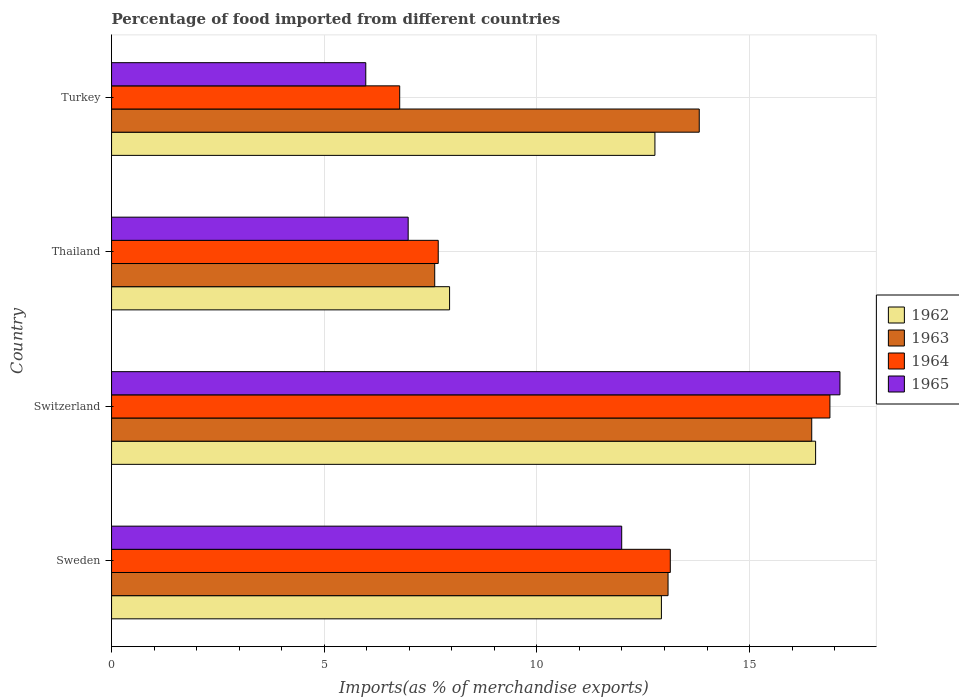How many different coloured bars are there?
Offer a terse response. 4. How many groups of bars are there?
Offer a terse response. 4. Are the number of bars on each tick of the Y-axis equal?
Offer a terse response. Yes. How many bars are there on the 4th tick from the top?
Offer a terse response. 4. How many bars are there on the 1st tick from the bottom?
Make the answer very short. 4. What is the label of the 2nd group of bars from the top?
Make the answer very short. Thailand. What is the percentage of imports to different countries in 1965 in Switzerland?
Make the answer very short. 17.12. Across all countries, what is the maximum percentage of imports to different countries in 1965?
Give a very brief answer. 17.12. Across all countries, what is the minimum percentage of imports to different countries in 1962?
Your response must be concise. 7.95. In which country was the percentage of imports to different countries in 1963 maximum?
Your answer should be very brief. Switzerland. In which country was the percentage of imports to different countries in 1962 minimum?
Provide a succinct answer. Thailand. What is the total percentage of imports to different countries in 1965 in the graph?
Ensure brevity in your answer.  42.07. What is the difference between the percentage of imports to different countries in 1964 in Sweden and that in Turkey?
Provide a succinct answer. 6.36. What is the difference between the percentage of imports to different countries in 1964 in Switzerland and the percentage of imports to different countries in 1962 in Thailand?
Your answer should be very brief. 8.94. What is the average percentage of imports to different countries in 1964 per country?
Offer a terse response. 11.12. What is the difference between the percentage of imports to different countries in 1962 and percentage of imports to different countries in 1964 in Turkey?
Your answer should be very brief. 6. In how many countries, is the percentage of imports to different countries in 1964 greater than 15 %?
Give a very brief answer. 1. What is the ratio of the percentage of imports to different countries in 1963 in Sweden to that in Switzerland?
Make the answer very short. 0.79. Is the percentage of imports to different countries in 1965 in Switzerland less than that in Turkey?
Offer a terse response. No. Is the difference between the percentage of imports to different countries in 1962 in Sweden and Thailand greater than the difference between the percentage of imports to different countries in 1964 in Sweden and Thailand?
Make the answer very short. No. What is the difference between the highest and the second highest percentage of imports to different countries in 1962?
Your answer should be compact. 3.63. What is the difference between the highest and the lowest percentage of imports to different countries in 1963?
Give a very brief answer. 8.86. Is it the case that in every country, the sum of the percentage of imports to different countries in 1962 and percentage of imports to different countries in 1963 is greater than the sum of percentage of imports to different countries in 1965 and percentage of imports to different countries in 1964?
Offer a terse response. No. What does the 4th bar from the bottom in Thailand represents?
Your answer should be very brief. 1965. Is it the case that in every country, the sum of the percentage of imports to different countries in 1963 and percentage of imports to different countries in 1965 is greater than the percentage of imports to different countries in 1964?
Provide a short and direct response. Yes. Are all the bars in the graph horizontal?
Offer a terse response. Yes. How many countries are there in the graph?
Give a very brief answer. 4. Does the graph contain any zero values?
Provide a succinct answer. No. How many legend labels are there?
Give a very brief answer. 4. How are the legend labels stacked?
Offer a terse response. Vertical. What is the title of the graph?
Your answer should be very brief. Percentage of food imported from different countries. Does "2001" appear as one of the legend labels in the graph?
Offer a very short reply. No. What is the label or title of the X-axis?
Your response must be concise. Imports(as % of merchandise exports). What is the label or title of the Y-axis?
Give a very brief answer. Country. What is the Imports(as % of merchandise exports) of 1962 in Sweden?
Ensure brevity in your answer.  12.93. What is the Imports(as % of merchandise exports) of 1963 in Sweden?
Offer a terse response. 13.08. What is the Imports(as % of merchandise exports) of 1964 in Sweden?
Give a very brief answer. 13.14. What is the Imports(as % of merchandise exports) of 1965 in Sweden?
Your response must be concise. 11.99. What is the Imports(as % of merchandise exports) in 1962 in Switzerland?
Your answer should be compact. 16.55. What is the Imports(as % of merchandise exports) of 1963 in Switzerland?
Provide a succinct answer. 16.46. What is the Imports(as % of merchandise exports) in 1964 in Switzerland?
Provide a short and direct response. 16.89. What is the Imports(as % of merchandise exports) in 1965 in Switzerland?
Offer a terse response. 17.12. What is the Imports(as % of merchandise exports) of 1962 in Thailand?
Offer a terse response. 7.95. What is the Imports(as % of merchandise exports) of 1963 in Thailand?
Offer a very short reply. 7.6. What is the Imports(as % of merchandise exports) in 1964 in Thailand?
Give a very brief answer. 7.68. What is the Imports(as % of merchandise exports) of 1965 in Thailand?
Your answer should be compact. 6.97. What is the Imports(as % of merchandise exports) of 1962 in Turkey?
Offer a very short reply. 12.77. What is the Imports(as % of merchandise exports) of 1963 in Turkey?
Your answer should be very brief. 13.82. What is the Imports(as % of merchandise exports) in 1964 in Turkey?
Make the answer very short. 6.77. What is the Imports(as % of merchandise exports) of 1965 in Turkey?
Offer a terse response. 5.98. Across all countries, what is the maximum Imports(as % of merchandise exports) in 1962?
Offer a very short reply. 16.55. Across all countries, what is the maximum Imports(as % of merchandise exports) in 1963?
Your answer should be very brief. 16.46. Across all countries, what is the maximum Imports(as % of merchandise exports) of 1964?
Provide a short and direct response. 16.89. Across all countries, what is the maximum Imports(as % of merchandise exports) of 1965?
Keep it short and to the point. 17.12. Across all countries, what is the minimum Imports(as % of merchandise exports) in 1962?
Offer a terse response. 7.95. Across all countries, what is the minimum Imports(as % of merchandise exports) in 1963?
Keep it short and to the point. 7.6. Across all countries, what is the minimum Imports(as % of merchandise exports) in 1964?
Provide a succinct answer. 6.77. Across all countries, what is the minimum Imports(as % of merchandise exports) in 1965?
Keep it short and to the point. 5.98. What is the total Imports(as % of merchandise exports) in 1962 in the graph?
Make the answer very short. 50.2. What is the total Imports(as % of merchandise exports) of 1963 in the graph?
Your answer should be very brief. 50.96. What is the total Imports(as % of merchandise exports) in 1964 in the graph?
Keep it short and to the point. 44.48. What is the total Imports(as % of merchandise exports) of 1965 in the graph?
Give a very brief answer. 42.07. What is the difference between the Imports(as % of merchandise exports) of 1962 in Sweden and that in Switzerland?
Provide a succinct answer. -3.63. What is the difference between the Imports(as % of merchandise exports) in 1963 in Sweden and that in Switzerland?
Make the answer very short. -3.38. What is the difference between the Imports(as % of merchandise exports) in 1964 in Sweden and that in Switzerland?
Offer a very short reply. -3.75. What is the difference between the Imports(as % of merchandise exports) of 1965 in Sweden and that in Switzerland?
Provide a succinct answer. -5.13. What is the difference between the Imports(as % of merchandise exports) of 1962 in Sweden and that in Thailand?
Offer a terse response. 4.98. What is the difference between the Imports(as % of merchandise exports) in 1963 in Sweden and that in Thailand?
Offer a terse response. 5.49. What is the difference between the Imports(as % of merchandise exports) of 1964 in Sweden and that in Thailand?
Make the answer very short. 5.46. What is the difference between the Imports(as % of merchandise exports) in 1965 in Sweden and that in Thailand?
Your response must be concise. 5.02. What is the difference between the Imports(as % of merchandise exports) of 1962 in Sweden and that in Turkey?
Your answer should be very brief. 0.15. What is the difference between the Imports(as % of merchandise exports) of 1963 in Sweden and that in Turkey?
Your answer should be compact. -0.73. What is the difference between the Imports(as % of merchandise exports) of 1964 in Sweden and that in Turkey?
Ensure brevity in your answer.  6.36. What is the difference between the Imports(as % of merchandise exports) of 1965 in Sweden and that in Turkey?
Your answer should be compact. 6.02. What is the difference between the Imports(as % of merchandise exports) of 1962 in Switzerland and that in Thailand?
Provide a succinct answer. 8.61. What is the difference between the Imports(as % of merchandise exports) of 1963 in Switzerland and that in Thailand?
Make the answer very short. 8.86. What is the difference between the Imports(as % of merchandise exports) in 1964 in Switzerland and that in Thailand?
Offer a terse response. 9.21. What is the difference between the Imports(as % of merchandise exports) of 1965 in Switzerland and that in Thailand?
Your answer should be compact. 10.15. What is the difference between the Imports(as % of merchandise exports) in 1962 in Switzerland and that in Turkey?
Keep it short and to the point. 3.78. What is the difference between the Imports(as % of merchandise exports) of 1963 in Switzerland and that in Turkey?
Offer a very short reply. 2.64. What is the difference between the Imports(as % of merchandise exports) in 1964 in Switzerland and that in Turkey?
Your answer should be very brief. 10.11. What is the difference between the Imports(as % of merchandise exports) in 1965 in Switzerland and that in Turkey?
Your answer should be compact. 11.15. What is the difference between the Imports(as % of merchandise exports) of 1962 in Thailand and that in Turkey?
Your answer should be very brief. -4.83. What is the difference between the Imports(as % of merchandise exports) of 1963 in Thailand and that in Turkey?
Make the answer very short. -6.22. What is the difference between the Imports(as % of merchandise exports) in 1964 in Thailand and that in Turkey?
Make the answer very short. 0.91. What is the difference between the Imports(as % of merchandise exports) in 1965 in Thailand and that in Turkey?
Your answer should be very brief. 1. What is the difference between the Imports(as % of merchandise exports) of 1962 in Sweden and the Imports(as % of merchandise exports) of 1963 in Switzerland?
Provide a short and direct response. -3.53. What is the difference between the Imports(as % of merchandise exports) in 1962 in Sweden and the Imports(as % of merchandise exports) in 1964 in Switzerland?
Your answer should be compact. -3.96. What is the difference between the Imports(as % of merchandise exports) of 1962 in Sweden and the Imports(as % of merchandise exports) of 1965 in Switzerland?
Keep it short and to the point. -4.2. What is the difference between the Imports(as % of merchandise exports) of 1963 in Sweden and the Imports(as % of merchandise exports) of 1964 in Switzerland?
Your answer should be very brief. -3.81. What is the difference between the Imports(as % of merchandise exports) in 1963 in Sweden and the Imports(as % of merchandise exports) in 1965 in Switzerland?
Give a very brief answer. -4.04. What is the difference between the Imports(as % of merchandise exports) in 1964 in Sweden and the Imports(as % of merchandise exports) in 1965 in Switzerland?
Your answer should be very brief. -3.99. What is the difference between the Imports(as % of merchandise exports) in 1962 in Sweden and the Imports(as % of merchandise exports) in 1963 in Thailand?
Keep it short and to the point. 5.33. What is the difference between the Imports(as % of merchandise exports) of 1962 in Sweden and the Imports(as % of merchandise exports) of 1964 in Thailand?
Provide a succinct answer. 5.25. What is the difference between the Imports(as % of merchandise exports) of 1962 in Sweden and the Imports(as % of merchandise exports) of 1965 in Thailand?
Make the answer very short. 5.95. What is the difference between the Imports(as % of merchandise exports) in 1963 in Sweden and the Imports(as % of merchandise exports) in 1964 in Thailand?
Your response must be concise. 5.4. What is the difference between the Imports(as % of merchandise exports) in 1963 in Sweden and the Imports(as % of merchandise exports) in 1965 in Thailand?
Your response must be concise. 6.11. What is the difference between the Imports(as % of merchandise exports) in 1964 in Sweden and the Imports(as % of merchandise exports) in 1965 in Thailand?
Make the answer very short. 6.16. What is the difference between the Imports(as % of merchandise exports) of 1962 in Sweden and the Imports(as % of merchandise exports) of 1963 in Turkey?
Provide a short and direct response. -0.89. What is the difference between the Imports(as % of merchandise exports) of 1962 in Sweden and the Imports(as % of merchandise exports) of 1964 in Turkey?
Provide a short and direct response. 6.15. What is the difference between the Imports(as % of merchandise exports) of 1962 in Sweden and the Imports(as % of merchandise exports) of 1965 in Turkey?
Your answer should be compact. 6.95. What is the difference between the Imports(as % of merchandise exports) in 1963 in Sweden and the Imports(as % of merchandise exports) in 1964 in Turkey?
Your response must be concise. 6.31. What is the difference between the Imports(as % of merchandise exports) in 1963 in Sweden and the Imports(as % of merchandise exports) in 1965 in Turkey?
Your answer should be compact. 7.11. What is the difference between the Imports(as % of merchandise exports) of 1964 in Sweden and the Imports(as % of merchandise exports) of 1965 in Turkey?
Your answer should be compact. 7.16. What is the difference between the Imports(as % of merchandise exports) in 1962 in Switzerland and the Imports(as % of merchandise exports) in 1963 in Thailand?
Make the answer very short. 8.96. What is the difference between the Imports(as % of merchandise exports) in 1962 in Switzerland and the Imports(as % of merchandise exports) in 1964 in Thailand?
Keep it short and to the point. 8.87. What is the difference between the Imports(as % of merchandise exports) of 1962 in Switzerland and the Imports(as % of merchandise exports) of 1965 in Thailand?
Keep it short and to the point. 9.58. What is the difference between the Imports(as % of merchandise exports) in 1963 in Switzerland and the Imports(as % of merchandise exports) in 1964 in Thailand?
Your answer should be very brief. 8.78. What is the difference between the Imports(as % of merchandise exports) of 1963 in Switzerland and the Imports(as % of merchandise exports) of 1965 in Thailand?
Your response must be concise. 9.49. What is the difference between the Imports(as % of merchandise exports) of 1964 in Switzerland and the Imports(as % of merchandise exports) of 1965 in Thailand?
Your response must be concise. 9.92. What is the difference between the Imports(as % of merchandise exports) in 1962 in Switzerland and the Imports(as % of merchandise exports) in 1963 in Turkey?
Provide a short and direct response. 2.74. What is the difference between the Imports(as % of merchandise exports) in 1962 in Switzerland and the Imports(as % of merchandise exports) in 1964 in Turkey?
Offer a very short reply. 9.78. What is the difference between the Imports(as % of merchandise exports) of 1962 in Switzerland and the Imports(as % of merchandise exports) of 1965 in Turkey?
Ensure brevity in your answer.  10.58. What is the difference between the Imports(as % of merchandise exports) of 1963 in Switzerland and the Imports(as % of merchandise exports) of 1964 in Turkey?
Offer a very short reply. 9.69. What is the difference between the Imports(as % of merchandise exports) in 1963 in Switzerland and the Imports(as % of merchandise exports) in 1965 in Turkey?
Your answer should be compact. 10.48. What is the difference between the Imports(as % of merchandise exports) in 1964 in Switzerland and the Imports(as % of merchandise exports) in 1965 in Turkey?
Give a very brief answer. 10.91. What is the difference between the Imports(as % of merchandise exports) of 1962 in Thailand and the Imports(as % of merchandise exports) of 1963 in Turkey?
Keep it short and to the point. -5.87. What is the difference between the Imports(as % of merchandise exports) of 1962 in Thailand and the Imports(as % of merchandise exports) of 1964 in Turkey?
Ensure brevity in your answer.  1.17. What is the difference between the Imports(as % of merchandise exports) of 1962 in Thailand and the Imports(as % of merchandise exports) of 1965 in Turkey?
Make the answer very short. 1.97. What is the difference between the Imports(as % of merchandise exports) of 1963 in Thailand and the Imports(as % of merchandise exports) of 1964 in Turkey?
Offer a terse response. 0.82. What is the difference between the Imports(as % of merchandise exports) of 1963 in Thailand and the Imports(as % of merchandise exports) of 1965 in Turkey?
Your answer should be very brief. 1.62. What is the difference between the Imports(as % of merchandise exports) in 1964 in Thailand and the Imports(as % of merchandise exports) in 1965 in Turkey?
Ensure brevity in your answer.  1.7. What is the average Imports(as % of merchandise exports) in 1962 per country?
Make the answer very short. 12.55. What is the average Imports(as % of merchandise exports) of 1963 per country?
Offer a terse response. 12.74. What is the average Imports(as % of merchandise exports) in 1964 per country?
Offer a terse response. 11.12. What is the average Imports(as % of merchandise exports) of 1965 per country?
Provide a succinct answer. 10.52. What is the difference between the Imports(as % of merchandise exports) in 1962 and Imports(as % of merchandise exports) in 1963 in Sweden?
Provide a succinct answer. -0.16. What is the difference between the Imports(as % of merchandise exports) in 1962 and Imports(as % of merchandise exports) in 1964 in Sweden?
Give a very brief answer. -0.21. What is the difference between the Imports(as % of merchandise exports) of 1962 and Imports(as % of merchandise exports) of 1965 in Sweden?
Provide a short and direct response. 0.93. What is the difference between the Imports(as % of merchandise exports) of 1963 and Imports(as % of merchandise exports) of 1964 in Sweden?
Provide a short and direct response. -0.05. What is the difference between the Imports(as % of merchandise exports) of 1963 and Imports(as % of merchandise exports) of 1965 in Sweden?
Your answer should be compact. 1.09. What is the difference between the Imports(as % of merchandise exports) in 1964 and Imports(as % of merchandise exports) in 1965 in Sweden?
Make the answer very short. 1.14. What is the difference between the Imports(as % of merchandise exports) of 1962 and Imports(as % of merchandise exports) of 1963 in Switzerland?
Your answer should be very brief. 0.09. What is the difference between the Imports(as % of merchandise exports) in 1962 and Imports(as % of merchandise exports) in 1964 in Switzerland?
Provide a short and direct response. -0.34. What is the difference between the Imports(as % of merchandise exports) in 1962 and Imports(as % of merchandise exports) in 1965 in Switzerland?
Offer a terse response. -0.57. What is the difference between the Imports(as % of merchandise exports) in 1963 and Imports(as % of merchandise exports) in 1964 in Switzerland?
Your answer should be very brief. -0.43. What is the difference between the Imports(as % of merchandise exports) in 1963 and Imports(as % of merchandise exports) in 1965 in Switzerland?
Ensure brevity in your answer.  -0.66. What is the difference between the Imports(as % of merchandise exports) in 1964 and Imports(as % of merchandise exports) in 1965 in Switzerland?
Provide a short and direct response. -0.24. What is the difference between the Imports(as % of merchandise exports) in 1962 and Imports(as % of merchandise exports) in 1963 in Thailand?
Ensure brevity in your answer.  0.35. What is the difference between the Imports(as % of merchandise exports) in 1962 and Imports(as % of merchandise exports) in 1964 in Thailand?
Offer a very short reply. 0.27. What is the difference between the Imports(as % of merchandise exports) of 1962 and Imports(as % of merchandise exports) of 1965 in Thailand?
Provide a succinct answer. 0.97. What is the difference between the Imports(as % of merchandise exports) in 1963 and Imports(as % of merchandise exports) in 1964 in Thailand?
Offer a very short reply. -0.08. What is the difference between the Imports(as % of merchandise exports) in 1963 and Imports(as % of merchandise exports) in 1965 in Thailand?
Give a very brief answer. 0.62. What is the difference between the Imports(as % of merchandise exports) of 1964 and Imports(as % of merchandise exports) of 1965 in Thailand?
Offer a terse response. 0.71. What is the difference between the Imports(as % of merchandise exports) of 1962 and Imports(as % of merchandise exports) of 1963 in Turkey?
Provide a succinct answer. -1.04. What is the difference between the Imports(as % of merchandise exports) in 1962 and Imports(as % of merchandise exports) in 1964 in Turkey?
Offer a terse response. 6. What is the difference between the Imports(as % of merchandise exports) in 1962 and Imports(as % of merchandise exports) in 1965 in Turkey?
Offer a terse response. 6.8. What is the difference between the Imports(as % of merchandise exports) in 1963 and Imports(as % of merchandise exports) in 1964 in Turkey?
Your response must be concise. 7.04. What is the difference between the Imports(as % of merchandise exports) in 1963 and Imports(as % of merchandise exports) in 1965 in Turkey?
Offer a terse response. 7.84. What is the difference between the Imports(as % of merchandise exports) of 1964 and Imports(as % of merchandise exports) of 1965 in Turkey?
Your response must be concise. 0.8. What is the ratio of the Imports(as % of merchandise exports) in 1962 in Sweden to that in Switzerland?
Your answer should be compact. 0.78. What is the ratio of the Imports(as % of merchandise exports) of 1963 in Sweden to that in Switzerland?
Make the answer very short. 0.79. What is the ratio of the Imports(as % of merchandise exports) in 1964 in Sweden to that in Switzerland?
Offer a terse response. 0.78. What is the ratio of the Imports(as % of merchandise exports) in 1965 in Sweden to that in Switzerland?
Give a very brief answer. 0.7. What is the ratio of the Imports(as % of merchandise exports) in 1962 in Sweden to that in Thailand?
Ensure brevity in your answer.  1.63. What is the ratio of the Imports(as % of merchandise exports) of 1963 in Sweden to that in Thailand?
Make the answer very short. 1.72. What is the ratio of the Imports(as % of merchandise exports) in 1964 in Sweden to that in Thailand?
Ensure brevity in your answer.  1.71. What is the ratio of the Imports(as % of merchandise exports) of 1965 in Sweden to that in Thailand?
Offer a terse response. 1.72. What is the ratio of the Imports(as % of merchandise exports) in 1962 in Sweden to that in Turkey?
Your answer should be very brief. 1.01. What is the ratio of the Imports(as % of merchandise exports) in 1963 in Sweden to that in Turkey?
Ensure brevity in your answer.  0.95. What is the ratio of the Imports(as % of merchandise exports) of 1964 in Sweden to that in Turkey?
Make the answer very short. 1.94. What is the ratio of the Imports(as % of merchandise exports) of 1965 in Sweden to that in Turkey?
Ensure brevity in your answer.  2.01. What is the ratio of the Imports(as % of merchandise exports) of 1962 in Switzerland to that in Thailand?
Your answer should be very brief. 2.08. What is the ratio of the Imports(as % of merchandise exports) of 1963 in Switzerland to that in Thailand?
Your answer should be compact. 2.17. What is the ratio of the Imports(as % of merchandise exports) in 1964 in Switzerland to that in Thailand?
Ensure brevity in your answer.  2.2. What is the ratio of the Imports(as % of merchandise exports) in 1965 in Switzerland to that in Thailand?
Provide a succinct answer. 2.46. What is the ratio of the Imports(as % of merchandise exports) of 1962 in Switzerland to that in Turkey?
Provide a short and direct response. 1.3. What is the ratio of the Imports(as % of merchandise exports) in 1963 in Switzerland to that in Turkey?
Ensure brevity in your answer.  1.19. What is the ratio of the Imports(as % of merchandise exports) in 1964 in Switzerland to that in Turkey?
Offer a terse response. 2.49. What is the ratio of the Imports(as % of merchandise exports) of 1965 in Switzerland to that in Turkey?
Ensure brevity in your answer.  2.87. What is the ratio of the Imports(as % of merchandise exports) in 1962 in Thailand to that in Turkey?
Make the answer very short. 0.62. What is the ratio of the Imports(as % of merchandise exports) in 1963 in Thailand to that in Turkey?
Give a very brief answer. 0.55. What is the ratio of the Imports(as % of merchandise exports) of 1964 in Thailand to that in Turkey?
Ensure brevity in your answer.  1.13. What is the ratio of the Imports(as % of merchandise exports) in 1965 in Thailand to that in Turkey?
Your answer should be very brief. 1.17. What is the difference between the highest and the second highest Imports(as % of merchandise exports) of 1962?
Provide a short and direct response. 3.63. What is the difference between the highest and the second highest Imports(as % of merchandise exports) in 1963?
Ensure brevity in your answer.  2.64. What is the difference between the highest and the second highest Imports(as % of merchandise exports) in 1964?
Provide a short and direct response. 3.75. What is the difference between the highest and the second highest Imports(as % of merchandise exports) of 1965?
Provide a succinct answer. 5.13. What is the difference between the highest and the lowest Imports(as % of merchandise exports) of 1962?
Your response must be concise. 8.61. What is the difference between the highest and the lowest Imports(as % of merchandise exports) in 1963?
Your answer should be very brief. 8.86. What is the difference between the highest and the lowest Imports(as % of merchandise exports) in 1964?
Your answer should be very brief. 10.11. What is the difference between the highest and the lowest Imports(as % of merchandise exports) in 1965?
Your response must be concise. 11.15. 